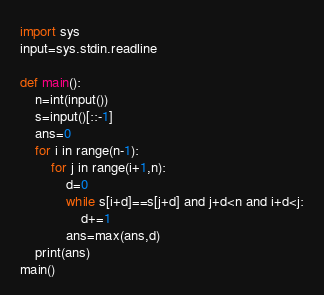<code> <loc_0><loc_0><loc_500><loc_500><_Python_>import sys
input=sys.stdin.readline

def main():
    n=int(input())
    s=input()[::-1]
    ans=0
    for i in range(n-1):
        for j in range(i+1,n):
            d=0
            while s[i+d]==s[j+d] and j+d<n and i+d<j:
                d+=1
            ans=max(ans,d)
    print(ans)
main()</code> 